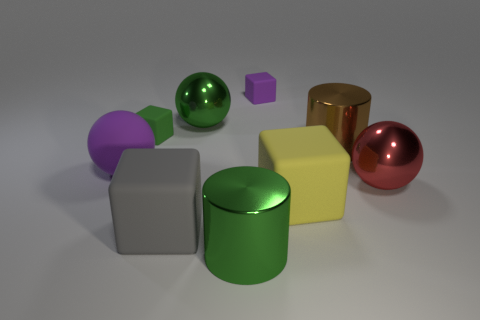Subtract all metal spheres. How many spheres are left? 1 Subtract all cylinders. How many objects are left? 7 Subtract all green cubes. How many cubes are left? 3 Subtract 0 gray spheres. How many objects are left? 9 Subtract all red cubes. Subtract all red cylinders. How many cubes are left? 4 Subtract all small matte cubes. Subtract all big rubber cubes. How many objects are left? 5 Add 8 big matte spheres. How many big matte spheres are left? 9 Add 5 big purple spheres. How many big purple spheres exist? 6 